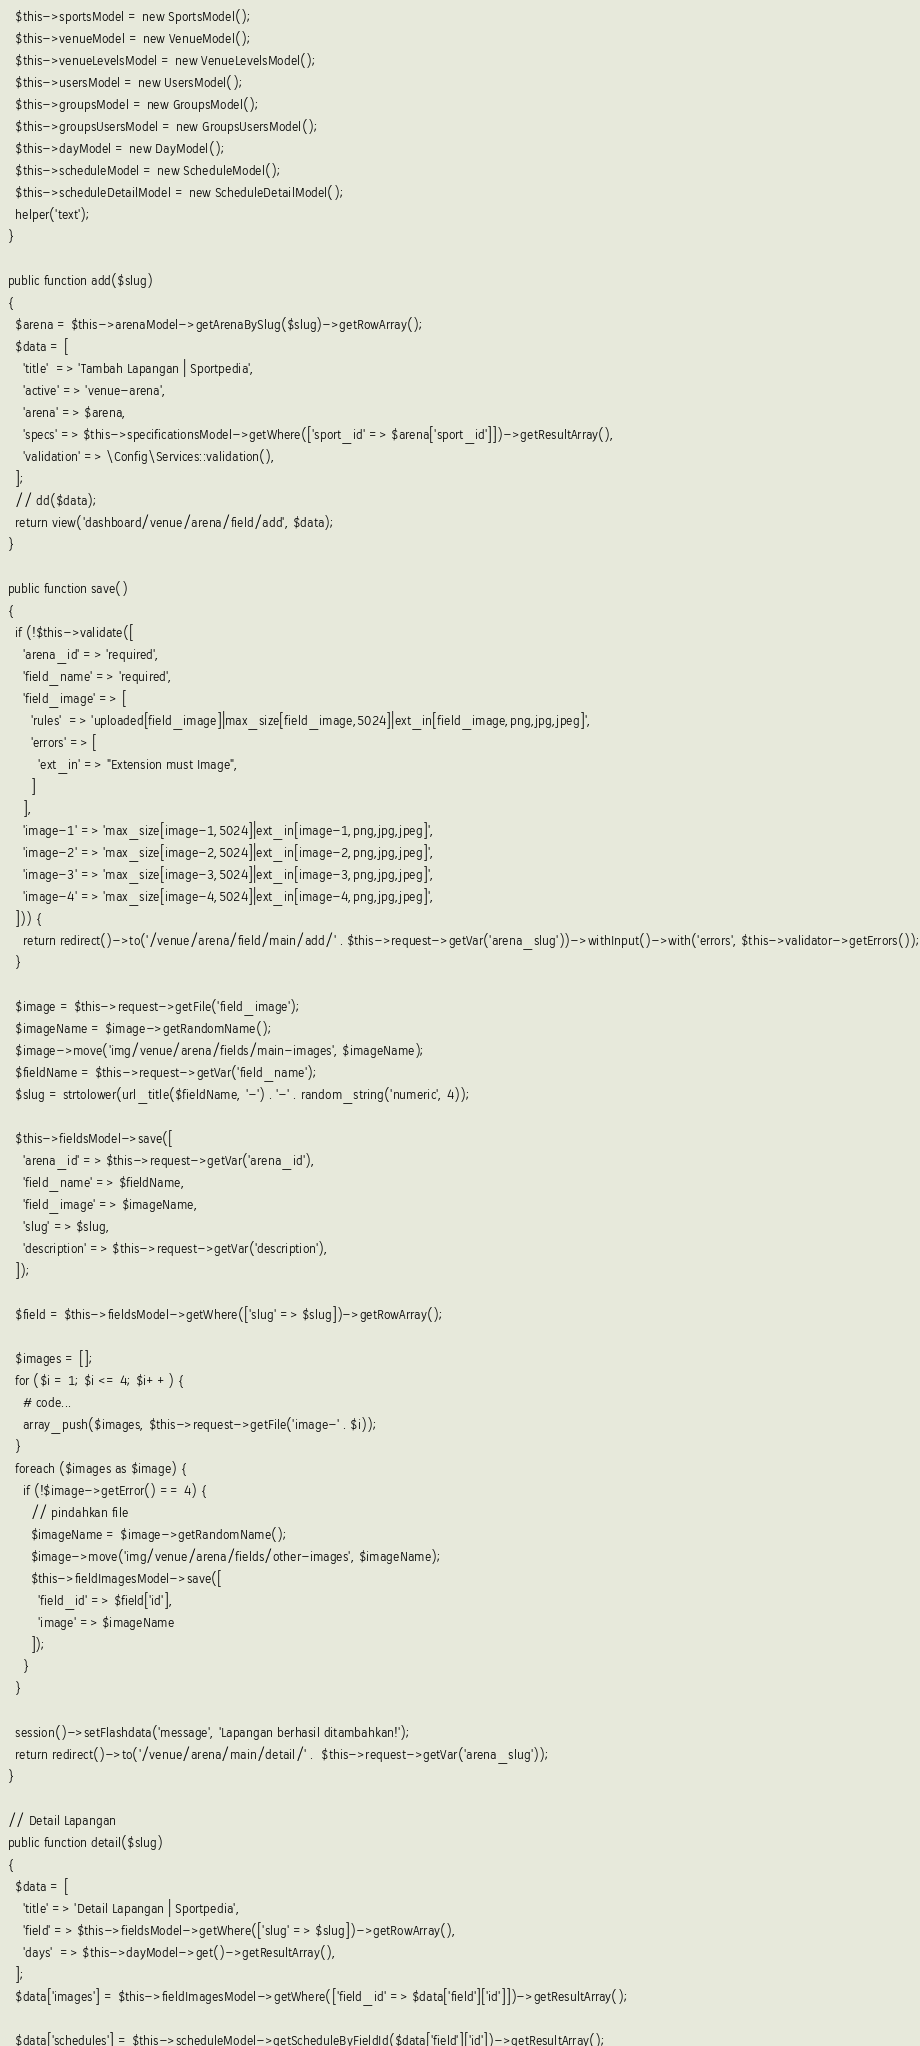Convert code to text. <code><loc_0><loc_0><loc_500><loc_500><_PHP_>    $this->sportsModel = new SportsModel();
    $this->venueModel = new VenueModel();
    $this->venueLevelsModel = new VenueLevelsModel();
    $this->usersModel = new UsersModel();
    $this->groupsModel = new GroupsModel();
    $this->groupsUsersModel = new GroupsUsersModel();
    $this->dayModel = new DayModel();
    $this->scheduleModel = new ScheduleModel();
    $this->scheduleDetailModel = new ScheduleDetailModel();
    helper('text');
  }

  public function add($slug)
  {
    $arena = $this->arenaModel->getArenaBySlug($slug)->getRowArray();
    $data = [
      'title'  => 'Tambah Lapangan | Sportpedia',
      'active' => 'venue-arena',
      'arena' => $arena,
      'specs' => $this->specificationsModel->getWhere(['sport_id' => $arena['sport_id']])->getResultArray(),
      'validation' => \Config\Services::validation(),
    ];
    // dd($data);
    return view('dashboard/venue/arena/field/add', $data);
  }

  public function save()
  {
    if (!$this->validate([
      'arena_id' => 'required',
      'field_name' => 'required',
      'field_image' => [
        'rules'  => 'uploaded[field_image]|max_size[field_image,5024]|ext_in[field_image,png,jpg,jpeg]',
        'errors' => [
          'ext_in' => "Extension must Image",
        ]
      ],
      'image-1' => 'max_size[image-1,5024]|ext_in[image-1,png,jpg,jpeg]',
      'image-2' => 'max_size[image-2,5024]|ext_in[image-2,png,jpg,jpeg]',
      'image-3' => 'max_size[image-3,5024]|ext_in[image-3,png,jpg,jpeg]',
      'image-4' => 'max_size[image-4,5024]|ext_in[image-4,png,jpg,jpeg]',
    ])) {
      return redirect()->to('/venue/arena/field/main/add/' . $this->request->getVar('arena_slug'))->withInput()->with('errors', $this->validator->getErrors());
    }

    $image = $this->request->getFile('field_image');
    $imageName = $image->getRandomName();
    $image->move('img/venue/arena/fields/main-images', $imageName);
    $fieldName = $this->request->getVar('field_name');
    $slug = strtolower(url_title($fieldName, '-') . '-' . random_string('numeric', 4));

    $this->fieldsModel->save([
      'arena_id' => $this->request->getVar('arena_id'),
      'field_name' => $fieldName,
      'field_image' => $imageName,
      'slug' => $slug,
      'description' => $this->request->getVar('description'),
    ]);

    $field = $this->fieldsModel->getWhere(['slug' => $slug])->getRowArray();

    $images = [];
    for ($i = 1; $i <= 4; $i++) {
      # code...
      array_push($images, $this->request->getFile('image-' . $i));
    }
    foreach ($images as $image) {
      if (!$image->getError() == 4) {
        // pindahkan file
        $imageName = $image->getRandomName();
        $image->move('img/venue/arena/fields/other-images', $imageName);
        $this->fieldImagesModel->save([
          'field_id' => $field['id'],
          'image' => $imageName
        ]);
      }
    }

    session()->setFlashdata('message', 'Lapangan berhasil ditambahkan!');
    return redirect()->to('/venue/arena/main/detail/' .  $this->request->getVar('arena_slug'));
  }

  // Detail Lapangan
  public function detail($slug)
  {
    $data = [
      'title' => 'Detail Lapangan | Sportpedia',
      'field' => $this->fieldsModel->getWhere(['slug' => $slug])->getRowArray(),
      'days'  => $this->dayModel->get()->getResultArray(),
    ];
    $data['images'] = $this->fieldImagesModel->getWhere(['field_id' => $data['field']['id']])->getResultArray();

    $data['schedules'] = $this->scheduleModel->getScheduleByFieldId($data['field']['id'])->getResultArray();</code> 